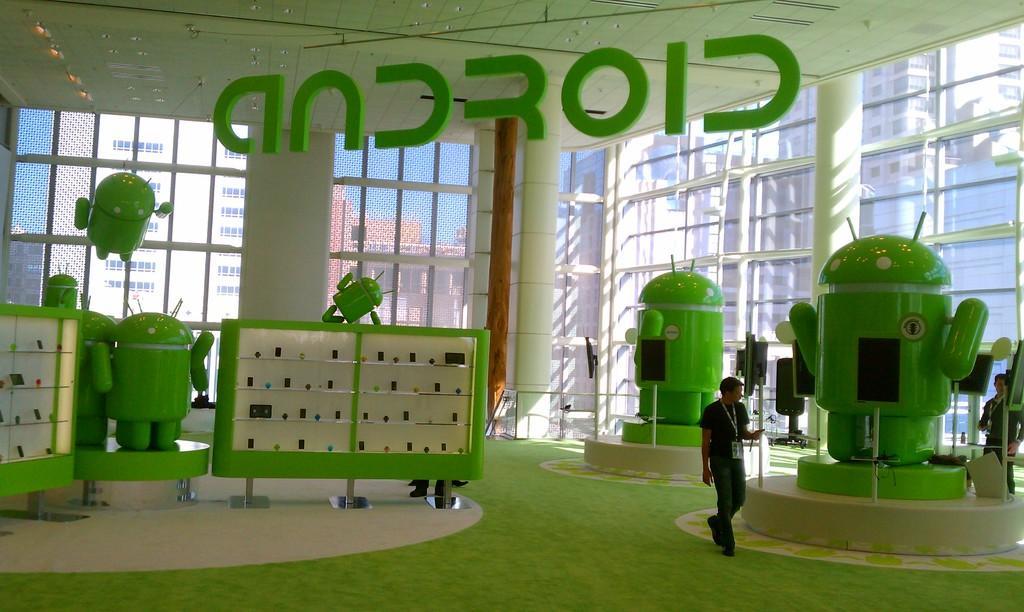How would you summarize this image in a sentence or two? In this picture we can see the room. In that room we can see a man who is standing near to the android shaped box. On the left we can see the racks. In the background we can see the buildings. Through the window we can see the sky. 